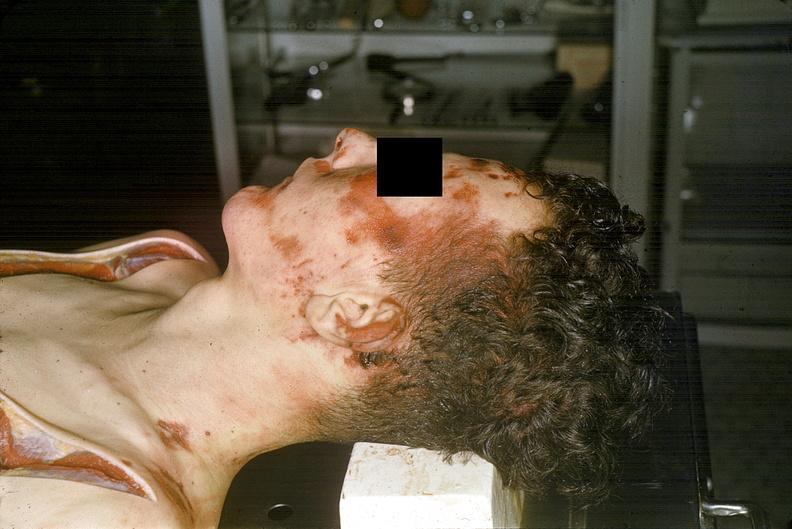does metastatic carcinoma prostate show head and face, severe trauma, contusion, lacerations, abrasions?
Answer the question using a single word or phrase. No 